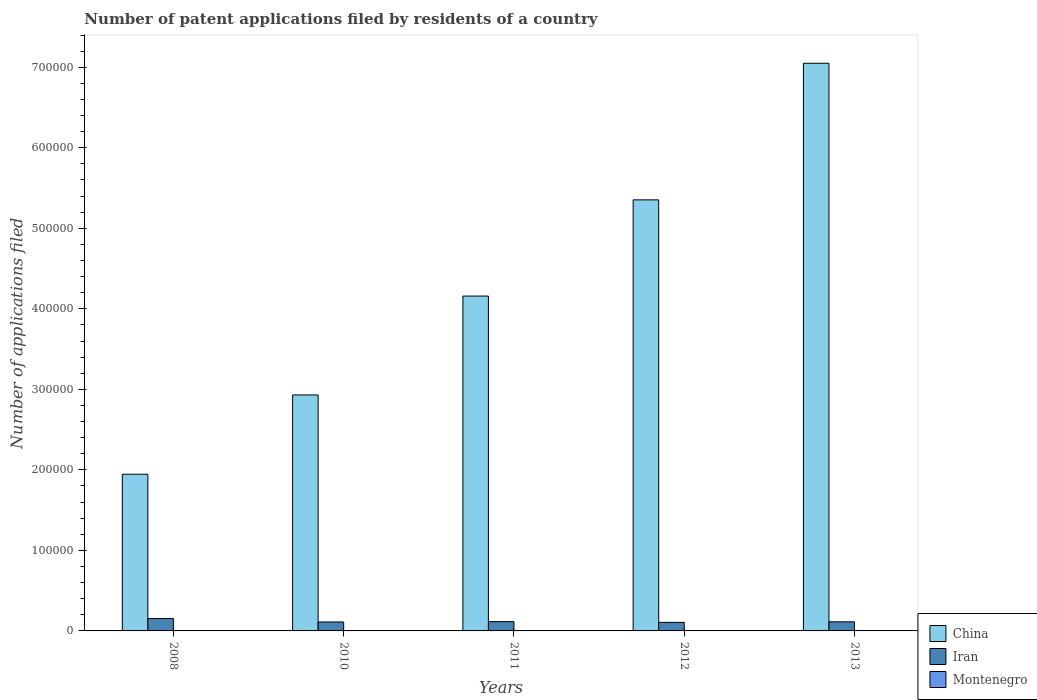How many groups of bars are there?
Offer a terse response. 5. Are the number of bars on each tick of the X-axis equal?
Offer a very short reply. Yes. What is the label of the 4th group of bars from the left?
Offer a terse response. 2012. What is the number of applications filed in Iran in 2008?
Provide a succinct answer. 1.54e+04. Across all years, what is the maximum number of applications filed in China?
Ensure brevity in your answer.  7.05e+05. Across all years, what is the minimum number of applications filed in Iran?
Offer a very short reply. 1.06e+04. What is the total number of applications filed in Iran in the graph?
Keep it short and to the point. 6.00e+04. What is the difference between the number of applications filed in Iran in 2010 and that in 2013?
Keep it short and to the point. -197. What is the difference between the number of applications filed in China in 2008 and the number of applications filed in Montenegro in 2012?
Offer a terse response. 1.95e+05. What is the average number of applications filed in Iran per year?
Keep it short and to the point. 1.20e+04. In the year 2013, what is the difference between the number of applications filed in China and number of applications filed in Montenegro?
Offer a terse response. 7.05e+05. In how many years, is the number of applications filed in Montenegro greater than 40000?
Your response must be concise. 0. What is the ratio of the number of applications filed in China in 2008 to that in 2013?
Your answer should be compact. 0.28. Is the number of applications filed in Montenegro in 2010 less than that in 2011?
Your response must be concise. No. Is the difference between the number of applications filed in China in 2010 and 2013 greater than the difference between the number of applications filed in Montenegro in 2010 and 2013?
Ensure brevity in your answer.  No. What is the difference between the highest and the second highest number of applications filed in China?
Your answer should be compact. 1.70e+05. What is the difference between the highest and the lowest number of applications filed in Iran?
Offer a terse response. 4781. In how many years, is the number of applications filed in Iran greater than the average number of applications filed in Iran taken over all years?
Your answer should be compact. 1. What does the 2nd bar from the left in 2010 represents?
Keep it short and to the point. Iran. What does the 2nd bar from the right in 2010 represents?
Provide a succinct answer. Iran. How many legend labels are there?
Offer a very short reply. 3. How are the legend labels stacked?
Provide a succinct answer. Vertical. What is the title of the graph?
Make the answer very short. Number of patent applications filed by residents of a country. What is the label or title of the X-axis?
Make the answer very short. Years. What is the label or title of the Y-axis?
Provide a short and direct response. Number of applications filed. What is the Number of applications filed of China in 2008?
Your answer should be very brief. 1.95e+05. What is the Number of applications filed of Iran in 2008?
Ensure brevity in your answer.  1.54e+04. What is the Number of applications filed of Montenegro in 2008?
Provide a succinct answer. 3. What is the Number of applications filed of China in 2010?
Your answer should be compact. 2.93e+05. What is the Number of applications filed of Iran in 2010?
Provide a succinct answer. 1.11e+04. What is the Number of applications filed in China in 2011?
Your answer should be compact. 4.16e+05. What is the Number of applications filed in Iran in 2011?
Keep it short and to the point. 1.15e+04. What is the Number of applications filed of China in 2012?
Ensure brevity in your answer.  5.35e+05. What is the Number of applications filed in Iran in 2012?
Ensure brevity in your answer.  1.06e+04. What is the Number of applications filed in China in 2013?
Ensure brevity in your answer.  7.05e+05. What is the Number of applications filed of Iran in 2013?
Your answer should be very brief. 1.13e+04. Across all years, what is the maximum Number of applications filed of China?
Make the answer very short. 7.05e+05. Across all years, what is the maximum Number of applications filed of Iran?
Provide a short and direct response. 1.54e+04. Across all years, what is the minimum Number of applications filed in China?
Ensure brevity in your answer.  1.95e+05. Across all years, what is the minimum Number of applications filed in Iran?
Provide a succinct answer. 1.06e+04. What is the total Number of applications filed of China in the graph?
Keep it short and to the point. 2.14e+06. What is the total Number of applications filed in Iran in the graph?
Offer a terse response. 6.00e+04. What is the total Number of applications filed of Montenegro in the graph?
Make the answer very short. 106. What is the difference between the Number of applications filed in China in 2008 and that in 2010?
Your answer should be compact. -9.85e+04. What is the difference between the Number of applications filed of Iran in 2008 and that in 2010?
Ensure brevity in your answer.  4295. What is the difference between the Number of applications filed in China in 2008 and that in 2011?
Keep it short and to the point. -2.21e+05. What is the difference between the Number of applications filed of Iran in 2008 and that in 2011?
Give a very brief answer. 3874. What is the difference between the Number of applications filed in China in 2008 and that in 2012?
Ensure brevity in your answer.  -3.41e+05. What is the difference between the Number of applications filed of Iran in 2008 and that in 2012?
Provide a succinct answer. 4781. What is the difference between the Number of applications filed in Montenegro in 2008 and that in 2012?
Keep it short and to the point. -34. What is the difference between the Number of applications filed in China in 2008 and that in 2013?
Make the answer very short. -5.10e+05. What is the difference between the Number of applications filed of Iran in 2008 and that in 2013?
Make the answer very short. 4098. What is the difference between the Number of applications filed in Montenegro in 2008 and that in 2013?
Offer a terse response. -20. What is the difference between the Number of applications filed in China in 2010 and that in 2011?
Make the answer very short. -1.23e+05. What is the difference between the Number of applications filed of Iran in 2010 and that in 2011?
Offer a very short reply. -421. What is the difference between the Number of applications filed in Montenegro in 2010 and that in 2011?
Provide a short and direct response. 3. What is the difference between the Number of applications filed in China in 2010 and that in 2012?
Ensure brevity in your answer.  -2.42e+05. What is the difference between the Number of applications filed of Iran in 2010 and that in 2012?
Ensure brevity in your answer.  486. What is the difference between the Number of applications filed of China in 2010 and that in 2013?
Provide a short and direct response. -4.12e+05. What is the difference between the Number of applications filed in Iran in 2010 and that in 2013?
Provide a short and direct response. -197. What is the difference between the Number of applications filed in China in 2011 and that in 2012?
Your answer should be very brief. -1.19e+05. What is the difference between the Number of applications filed in Iran in 2011 and that in 2012?
Provide a short and direct response. 907. What is the difference between the Number of applications filed of China in 2011 and that in 2013?
Your answer should be very brief. -2.89e+05. What is the difference between the Number of applications filed of Iran in 2011 and that in 2013?
Ensure brevity in your answer.  224. What is the difference between the Number of applications filed in China in 2012 and that in 2013?
Make the answer very short. -1.70e+05. What is the difference between the Number of applications filed in Iran in 2012 and that in 2013?
Your response must be concise. -683. What is the difference between the Number of applications filed in China in 2008 and the Number of applications filed in Iran in 2010?
Your answer should be compact. 1.83e+05. What is the difference between the Number of applications filed of China in 2008 and the Number of applications filed of Montenegro in 2010?
Ensure brevity in your answer.  1.95e+05. What is the difference between the Number of applications filed in Iran in 2008 and the Number of applications filed in Montenegro in 2010?
Your answer should be very brief. 1.54e+04. What is the difference between the Number of applications filed of China in 2008 and the Number of applications filed of Iran in 2011?
Offer a terse response. 1.83e+05. What is the difference between the Number of applications filed in China in 2008 and the Number of applications filed in Montenegro in 2011?
Offer a terse response. 1.95e+05. What is the difference between the Number of applications filed in Iran in 2008 and the Number of applications filed in Montenegro in 2011?
Offer a very short reply. 1.54e+04. What is the difference between the Number of applications filed in China in 2008 and the Number of applications filed in Iran in 2012?
Offer a terse response. 1.84e+05. What is the difference between the Number of applications filed of China in 2008 and the Number of applications filed of Montenegro in 2012?
Your response must be concise. 1.95e+05. What is the difference between the Number of applications filed in Iran in 2008 and the Number of applications filed in Montenegro in 2012?
Make the answer very short. 1.54e+04. What is the difference between the Number of applications filed in China in 2008 and the Number of applications filed in Iran in 2013?
Provide a succinct answer. 1.83e+05. What is the difference between the Number of applications filed of China in 2008 and the Number of applications filed of Montenegro in 2013?
Offer a very short reply. 1.95e+05. What is the difference between the Number of applications filed of Iran in 2008 and the Number of applications filed of Montenegro in 2013?
Your response must be concise. 1.54e+04. What is the difference between the Number of applications filed of China in 2010 and the Number of applications filed of Iran in 2011?
Give a very brief answer. 2.82e+05. What is the difference between the Number of applications filed of China in 2010 and the Number of applications filed of Montenegro in 2011?
Make the answer very short. 2.93e+05. What is the difference between the Number of applications filed of Iran in 2010 and the Number of applications filed of Montenegro in 2011?
Provide a succinct answer. 1.11e+04. What is the difference between the Number of applications filed of China in 2010 and the Number of applications filed of Iran in 2012?
Make the answer very short. 2.82e+05. What is the difference between the Number of applications filed in China in 2010 and the Number of applications filed in Montenegro in 2012?
Provide a succinct answer. 2.93e+05. What is the difference between the Number of applications filed in Iran in 2010 and the Number of applications filed in Montenegro in 2012?
Provide a succinct answer. 1.11e+04. What is the difference between the Number of applications filed in China in 2010 and the Number of applications filed in Iran in 2013?
Offer a very short reply. 2.82e+05. What is the difference between the Number of applications filed in China in 2010 and the Number of applications filed in Montenegro in 2013?
Provide a short and direct response. 2.93e+05. What is the difference between the Number of applications filed of Iran in 2010 and the Number of applications filed of Montenegro in 2013?
Keep it short and to the point. 1.11e+04. What is the difference between the Number of applications filed of China in 2011 and the Number of applications filed of Iran in 2012?
Give a very brief answer. 4.05e+05. What is the difference between the Number of applications filed of China in 2011 and the Number of applications filed of Montenegro in 2012?
Your answer should be very brief. 4.16e+05. What is the difference between the Number of applications filed in Iran in 2011 and the Number of applications filed in Montenegro in 2012?
Offer a very short reply. 1.15e+04. What is the difference between the Number of applications filed in China in 2011 and the Number of applications filed in Iran in 2013?
Make the answer very short. 4.05e+05. What is the difference between the Number of applications filed in China in 2011 and the Number of applications filed in Montenegro in 2013?
Offer a terse response. 4.16e+05. What is the difference between the Number of applications filed in Iran in 2011 and the Number of applications filed in Montenegro in 2013?
Your answer should be very brief. 1.15e+04. What is the difference between the Number of applications filed in China in 2012 and the Number of applications filed in Iran in 2013?
Give a very brief answer. 5.24e+05. What is the difference between the Number of applications filed in China in 2012 and the Number of applications filed in Montenegro in 2013?
Ensure brevity in your answer.  5.35e+05. What is the difference between the Number of applications filed in Iran in 2012 and the Number of applications filed in Montenegro in 2013?
Your answer should be very brief. 1.06e+04. What is the average Number of applications filed of China per year?
Offer a very short reply. 4.29e+05. What is the average Number of applications filed in Iran per year?
Your answer should be very brief. 1.20e+04. What is the average Number of applications filed of Montenegro per year?
Provide a succinct answer. 21.2. In the year 2008, what is the difference between the Number of applications filed of China and Number of applications filed of Iran?
Your answer should be compact. 1.79e+05. In the year 2008, what is the difference between the Number of applications filed of China and Number of applications filed of Montenegro?
Provide a succinct answer. 1.95e+05. In the year 2008, what is the difference between the Number of applications filed of Iran and Number of applications filed of Montenegro?
Keep it short and to the point. 1.54e+04. In the year 2010, what is the difference between the Number of applications filed in China and Number of applications filed in Iran?
Offer a very short reply. 2.82e+05. In the year 2010, what is the difference between the Number of applications filed in China and Number of applications filed in Montenegro?
Your response must be concise. 2.93e+05. In the year 2010, what is the difference between the Number of applications filed in Iran and Number of applications filed in Montenegro?
Your answer should be very brief. 1.11e+04. In the year 2011, what is the difference between the Number of applications filed of China and Number of applications filed of Iran?
Offer a very short reply. 4.04e+05. In the year 2011, what is the difference between the Number of applications filed of China and Number of applications filed of Montenegro?
Give a very brief answer. 4.16e+05. In the year 2011, what is the difference between the Number of applications filed of Iran and Number of applications filed of Montenegro?
Keep it short and to the point. 1.15e+04. In the year 2012, what is the difference between the Number of applications filed in China and Number of applications filed in Iran?
Your answer should be compact. 5.25e+05. In the year 2012, what is the difference between the Number of applications filed in China and Number of applications filed in Montenegro?
Ensure brevity in your answer.  5.35e+05. In the year 2012, what is the difference between the Number of applications filed in Iran and Number of applications filed in Montenegro?
Provide a succinct answer. 1.06e+04. In the year 2013, what is the difference between the Number of applications filed in China and Number of applications filed in Iran?
Give a very brief answer. 6.94e+05. In the year 2013, what is the difference between the Number of applications filed in China and Number of applications filed in Montenegro?
Ensure brevity in your answer.  7.05e+05. In the year 2013, what is the difference between the Number of applications filed of Iran and Number of applications filed of Montenegro?
Offer a very short reply. 1.13e+04. What is the ratio of the Number of applications filed of China in 2008 to that in 2010?
Ensure brevity in your answer.  0.66. What is the ratio of the Number of applications filed of Iran in 2008 to that in 2010?
Your answer should be very brief. 1.39. What is the ratio of the Number of applications filed in Montenegro in 2008 to that in 2010?
Offer a terse response. 0.13. What is the ratio of the Number of applications filed of China in 2008 to that in 2011?
Offer a terse response. 0.47. What is the ratio of the Number of applications filed in Iran in 2008 to that in 2011?
Keep it short and to the point. 1.34. What is the ratio of the Number of applications filed of Montenegro in 2008 to that in 2011?
Offer a very short reply. 0.15. What is the ratio of the Number of applications filed of China in 2008 to that in 2012?
Offer a terse response. 0.36. What is the ratio of the Number of applications filed of Iran in 2008 to that in 2012?
Keep it short and to the point. 1.45. What is the ratio of the Number of applications filed of Montenegro in 2008 to that in 2012?
Keep it short and to the point. 0.08. What is the ratio of the Number of applications filed of China in 2008 to that in 2013?
Offer a very short reply. 0.28. What is the ratio of the Number of applications filed in Iran in 2008 to that in 2013?
Provide a short and direct response. 1.36. What is the ratio of the Number of applications filed in Montenegro in 2008 to that in 2013?
Give a very brief answer. 0.13. What is the ratio of the Number of applications filed in China in 2010 to that in 2011?
Keep it short and to the point. 0.7. What is the ratio of the Number of applications filed of Iran in 2010 to that in 2011?
Provide a short and direct response. 0.96. What is the ratio of the Number of applications filed in Montenegro in 2010 to that in 2011?
Your answer should be very brief. 1.15. What is the ratio of the Number of applications filed of China in 2010 to that in 2012?
Provide a short and direct response. 0.55. What is the ratio of the Number of applications filed of Iran in 2010 to that in 2012?
Give a very brief answer. 1.05. What is the ratio of the Number of applications filed of Montenegro in 2010 to that in 2012?
Keep it short and to the point. 0.62. What is the ratio of the Number of applications filed in China in 2010 to that in 2013?
Make the answer very short. 0.42. What is the ratio of the Number of applications filed in Iran in 2010 to that in 2013?
Provide a succinct answer. 0.98. What is the ratio of the Number of applications filed of China in 2011 to that in 2012?
Your answer should be very brief. 0.78. What is the ratio of the Number of applications filed of Iran in 2011 to that in 2012?
Your answer should be compact. 1.09. What is the ratio of the Number of applications filed of Montenegro in 2011 to that in 2012?
Your answer should be compact. 0.54. What is the ratio of the Number of applications filed in China in 2011 to that in 2013?
Your answer should be very brief. 0.59. What is the ratio of the Number of applications filed in Iran in 2011 to that in 2013?
Keep it short and to the point. 1.02. What is the ratio of the Number of applications filed in Montenegro in 2011 to that in 2013?
Give a very brief answer. 0.87. What is the ratio of the Number of applications filed of China in 2012 to that in 2013?
Ensure brevity in your answer.  0.76. What is the ratio of the Number of applications filed of Iran in 2012 to that in 2013?
Your response must be concise. 0.94. What is the ratio of the Number of applications filed of Montenegro in 2012 to that in 2013?
Your response must be concise. 1.61. What is the difference between the highest and the second highest Number of applications filed in China?
Your answer should be compact. 1.70e+05. What is the difference between the highest and the second highest Number of applications filed of Iran?
Your answer should be very brief. 3874. What is the difference between the highest and the second highest Number of applications filed of Montenegro?
Ensure brevity in your answer.  14. What is the difference between the highest and the lowest Number of applications filed in China?
Make the answer very short. 5.10e+05. What is the difference between the highest and the lowest Number of applications filed of Iran?
Make the answer very short. 4781. What is the difference between the highest and the lowest Number of applications filed of Montenegro?
Offer a terse response. 34. 